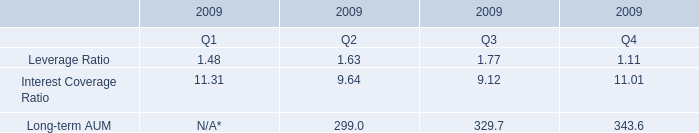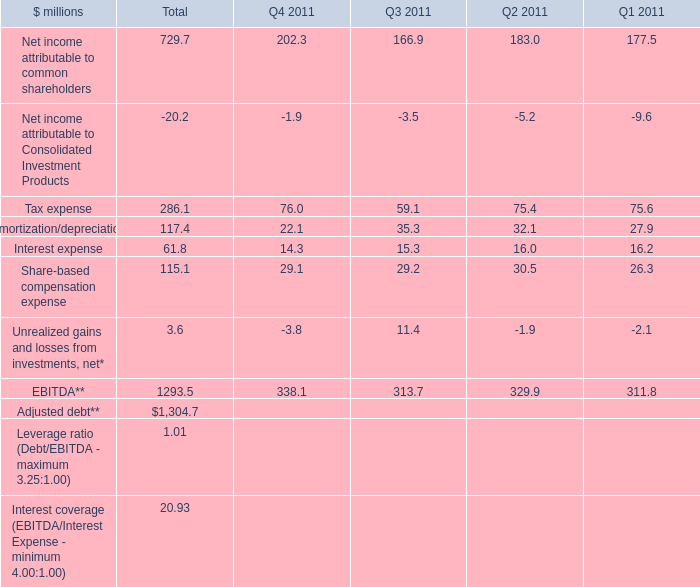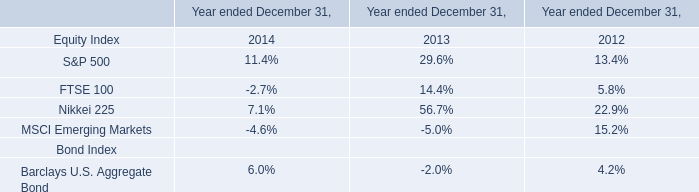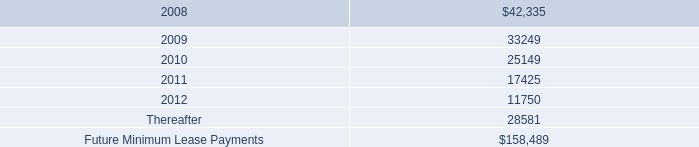what was the percentage change in rental expense from 2005 to 2006? 
Computations: ((18.6 - 12.2) / 12.2)
Answer: 0.52459. 